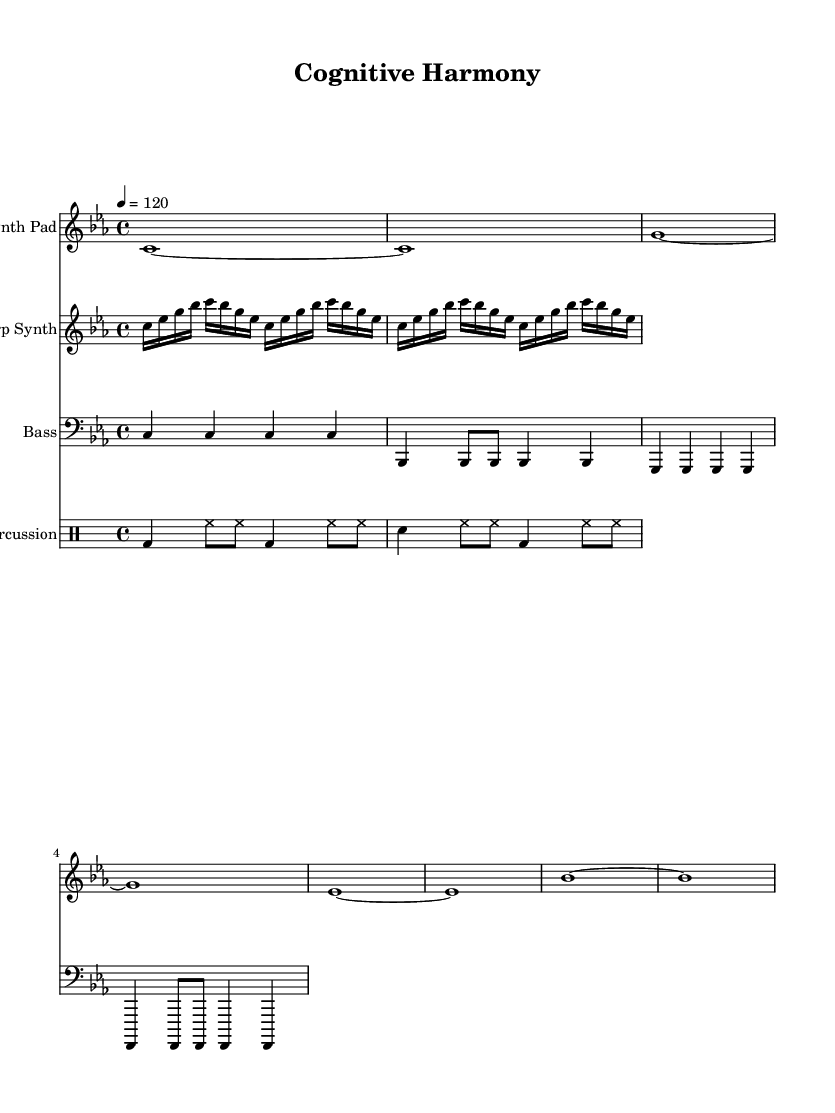What is the key signature of this music? The key signature is indicated at the beginning of the score, which shows three flats: B flat, E flat, and A flat. This identifies the key as C minor.
Answer: C minor What is the time signature of this music? The time signature can be found at the start of the score, shown as 4 over 4, which means there are four beats in a measure and the quarter note gets one beat.
Answer: 4/4 What is the tempo marking in this music? The tempo marking in the score indicates the speed at which the piece should be played. It is marked as "4 = 120," meaning there are 120 quarter-note beats per minute.
Answer: 120 How many measures are in the Synth Pad part? To find the number of measures, we count the vertical bar lines in the Synth Pad part, which separates the measures. There are eight measures as represented by eight bar lines.
Answer: 8 What instrument is indicated for the Arp Synth part? The Arp Synth part is labeled at the start of its staff with "Arp Synth" as the instrument name, confirming which instrument is to be played.
Answer: Arp Synth What rhythmic pattern is used in the percussion part? The percussion part shows a combination of bass drum, hi-hat, and snare drum patterns. The rhythmic structure consists of alternate bass drum hits and alternating hi-hat and snare combinations, creating a consistent beat.
Answer: Alternating bass and hi-hat Which notes are primarily used in the Bass part? The Bass part consists of repeated notes that include C, B flat, G, and F, as seen throughout the measures. These notes provide the harmonic foundation for the piece.
Answer: C, B flat, G, F 